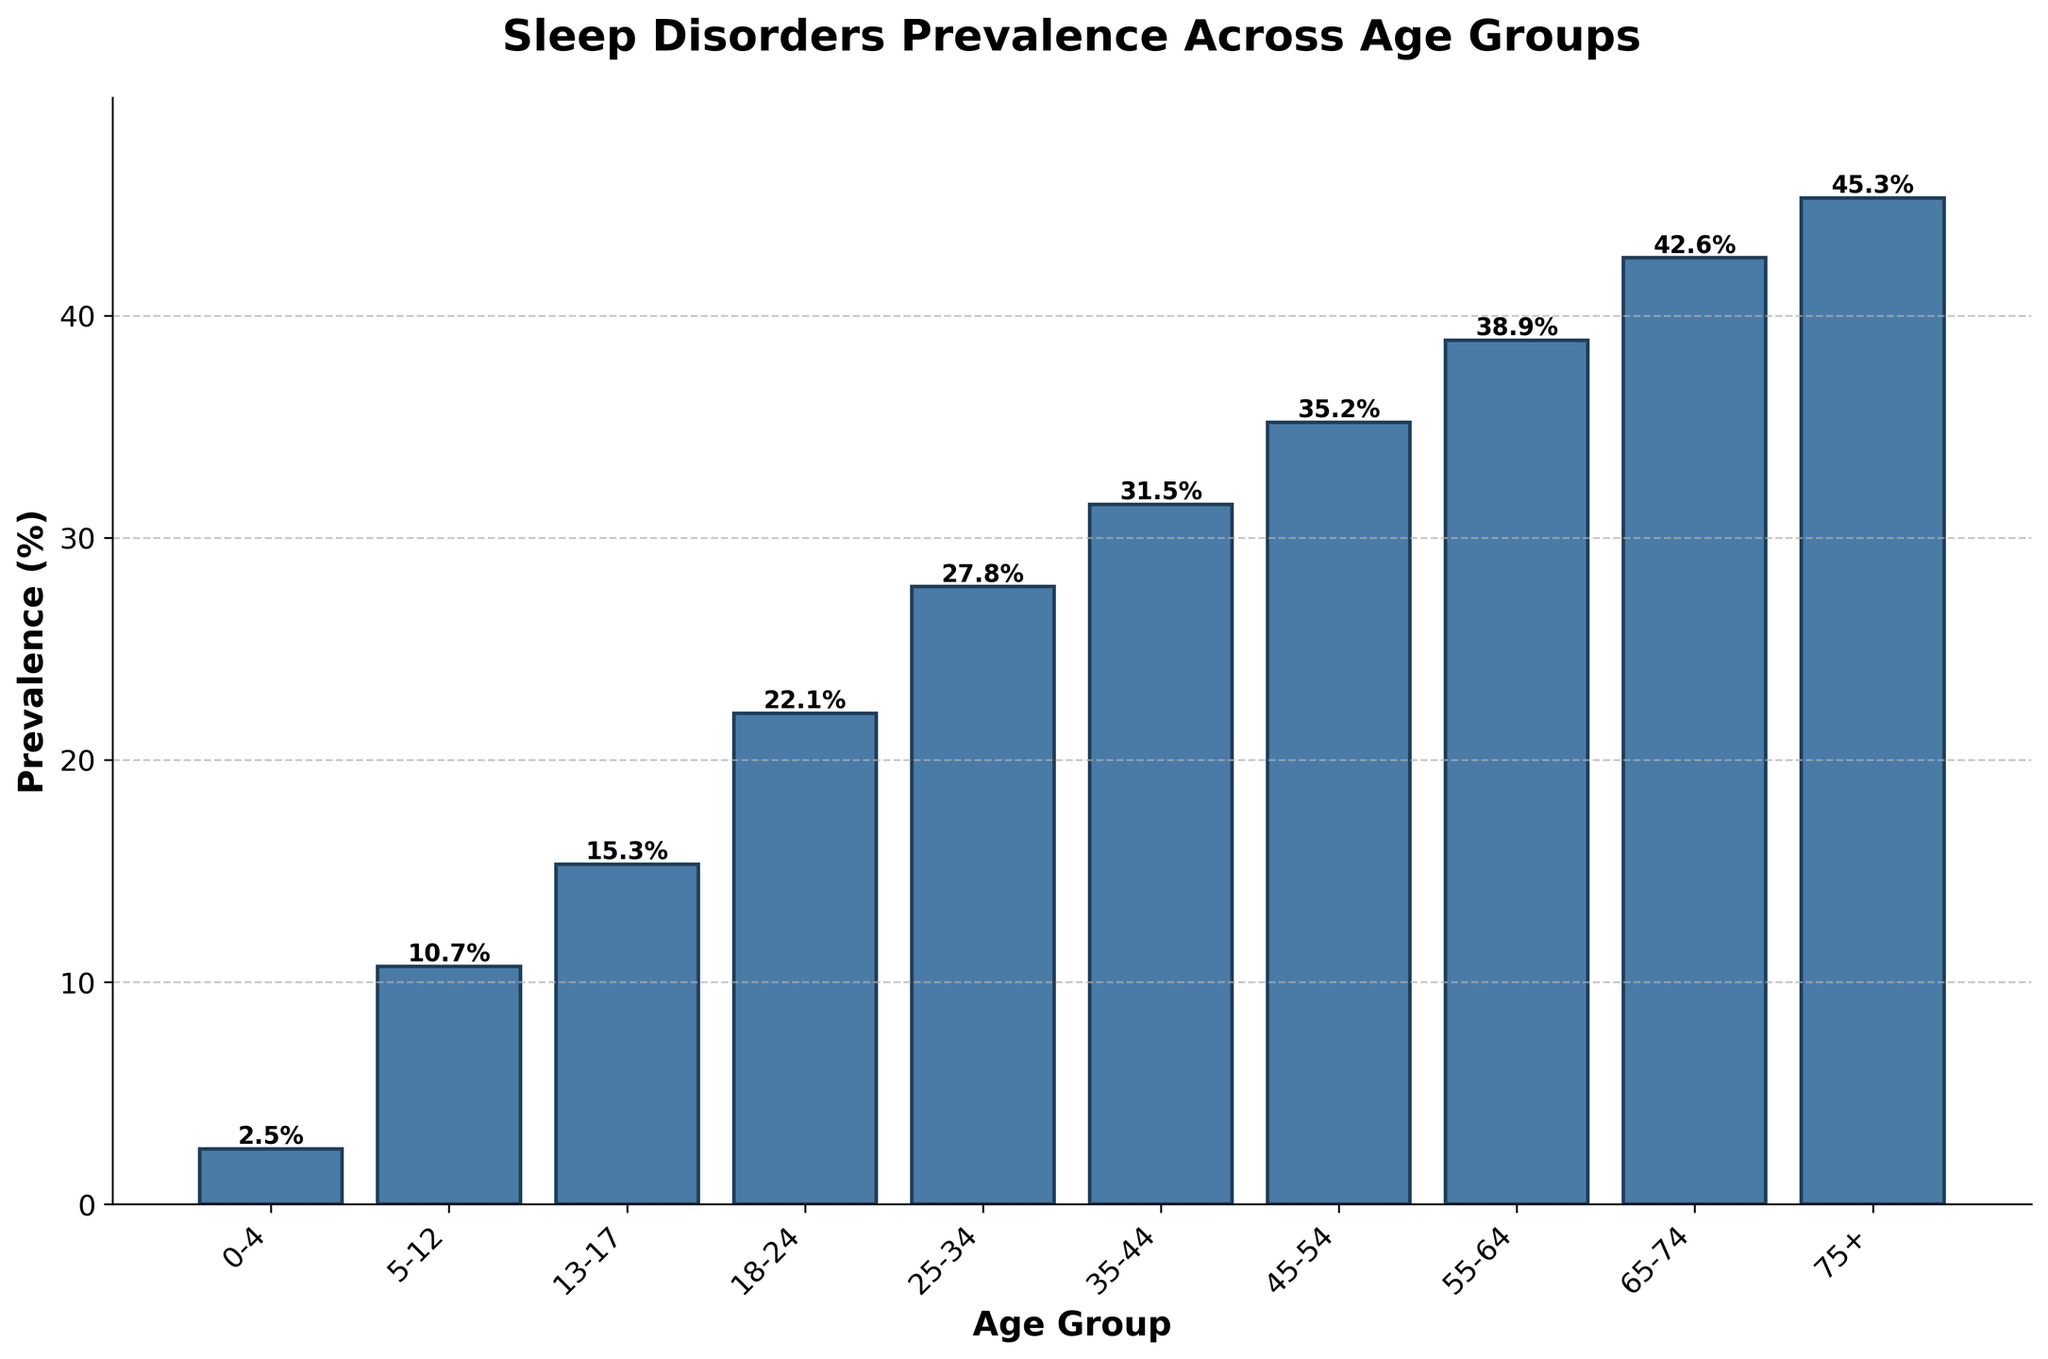What is the highest prevalence percentage for any age group? The highest bar in the chart represents the age group 75+ with a prevalence percentage of 45.3%.
Answer: 45.3% Which age group has the highest prevalence of sleep disorders? The tallest bar, which corresponds to the age group 75+, indicates the highest prevalence.
Answer: 75+ Compare the prevalence percentages between age groups 0-4 and 75+. Which is higher and by how much? The prevalence for age group 0-4 is 2.5%, and for age group 75+ it is 45.3%. The difference is calculated as 45.3% - 2.5% = 42.8%.
Answer: 75+ is higher by 42.8% How does the prevalence percentage change from age group 18-24 to 25-34? The bar for age group 18-24 shows a prevalence of 22.1%, and the bar for age group 25-34 shows 27.8%. The difference is 27.8% - 22.1% = 5.7%, indicating an increase.
Answer: Increases by 5.7% What is the average prevalence percentage for all age groups? Sum the prevalence percentages and divide by the number of age groups: (2.5 + 10.7 + 15.3 + 22.1 + 27.8 + 31.5 + 35.2 + 38.9 + 42.6 + 45.3) / 10 = 272.9 / 10 = 27.29%.
Answer: 27.29% Which age groups have a prevalence percentage greater than 30%? The bars for age groups 35-44, 45-54, 55-64, 65-74, and 75+ all extend above the 30% mark.
Answer: 35-44, 45-54, 55-64, 65-74, 75+ Is there any age group with a prevalence percentage below 5%? The bar for the age group 0-4 shows a prevalence percentage of 2.5%, which is below 5%.
Answer: Yes, 0-4 What is the difference in prevalence percentage between the smallest and largest age groups? The smallest age group (0-4) has a prevalence of 2.5%, and the largest (75+) has 45.3%. The difference is calculated as 45.3% - 2.5% = 42.8%.
Answer: 42.8% How many age groups have a prevalence percentage above the average prevalence? The average prevalence is 27.29%. The bars for age groups 35-44, 45-54, 55-64, 65-74, and 75+ lie above the average.
Answer: 5 What visual element indicates that the prevalence in older age groups is higher? The height of the bars increases as the age groups progress from younger to older, with the tallest bars representing the oldest age groups.
Answer: Increasing bar height 